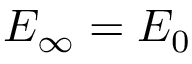<formula> <loc_0><loc_0><loc_500><loc_500>E _ { \infty } = E _ { 0 }</formula> 